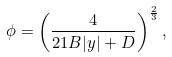Convert formula to latex. <formula><loc_0><loc_0><loc_500><loc_500>\phi = \left ( \frac { 4 } { 2 1 B | y | + D } \right ) ^ { \frac { 2 } { 3 } } ,</formula> 